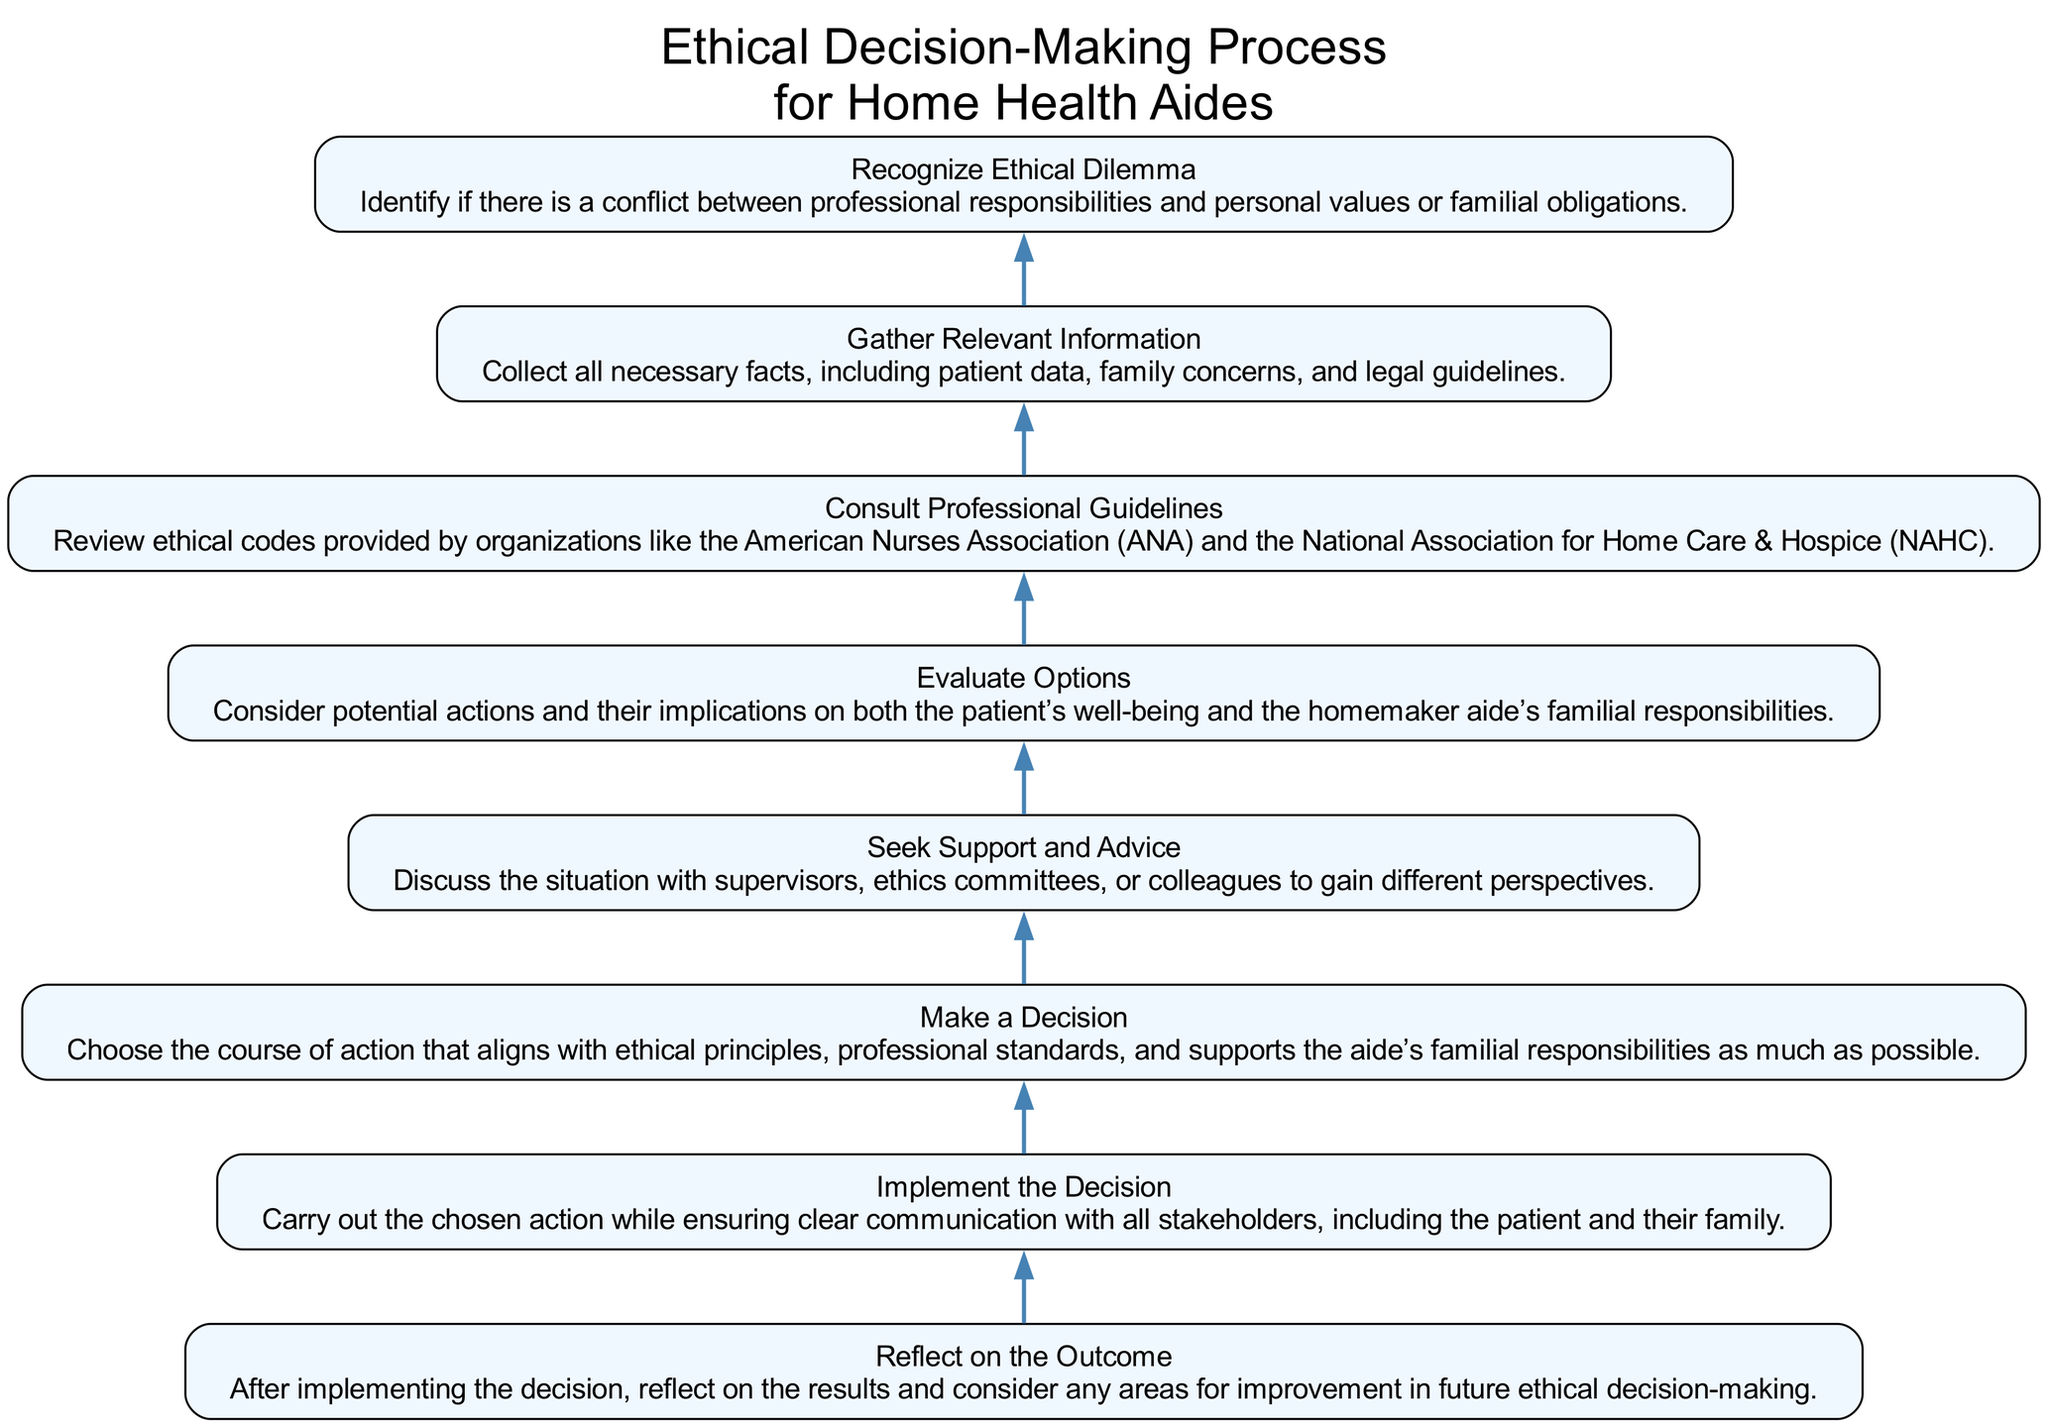What is the first step in the ethical decision-making process? The first step is recognized by looking at the bottom of the diagram. The lowest node indicates "Recognize Ethical Dilemma," which signals the starting point of the process.
Answer: Recognize Ethical Dilemma How many steps are there in total in the diagram? By counting the number of distinct nodes listed in the diagram, the total number of steps can be identified. There are eight nodes in the flowchart.
Answer: Eight What step follows "Gather Relevant Information"? Following "Gather Relevant Information," we look for the subsequent node directly above it in the flow. The next node is "Consult Professional Guidelines."
Answer: Consult Professional Guidelines Which step emphasizes the importance of reflection? At the top of the diagram, the last step is "Reflect on the Outcome," which indicates the importance of assessing the decision made.
Answer: Reflect on the Outcome What is the relationship between "Evaluate Options" and "Consult Professional Guidelines"? By tracing the arrows in the flowchart, we see that "Evaluate Options" occurs after "Consult Professional Guidelines" and shows the sequence of steps. It indicates that consulting guidelines informs the evaluation of options.
Answer: Evaluate Options follows Consult Professional Guidelines What is the main focus of the "Seek Support and Advice" step? The description of this step highlights discussing the situation with others to gain different perspectives and insights, focusing on collaboration and support in decision-making.
Answer: Collaboration and support How does the "Make a Decision" step relate to familial responsibilities? This step notes that the decision should align with ethical principles and professional standards while also considering the aide's familial responsibilities, illustrating a balance between work and personal life.
Answer: Balancing work and personal life What should be done after implementing the decision? The flowchart indicates that after "Implement the Decision," the next step is to "Reflect on the Outcome," suggesting that reflection is crucial after taking action.
Answer: Reflect on the Outcome 